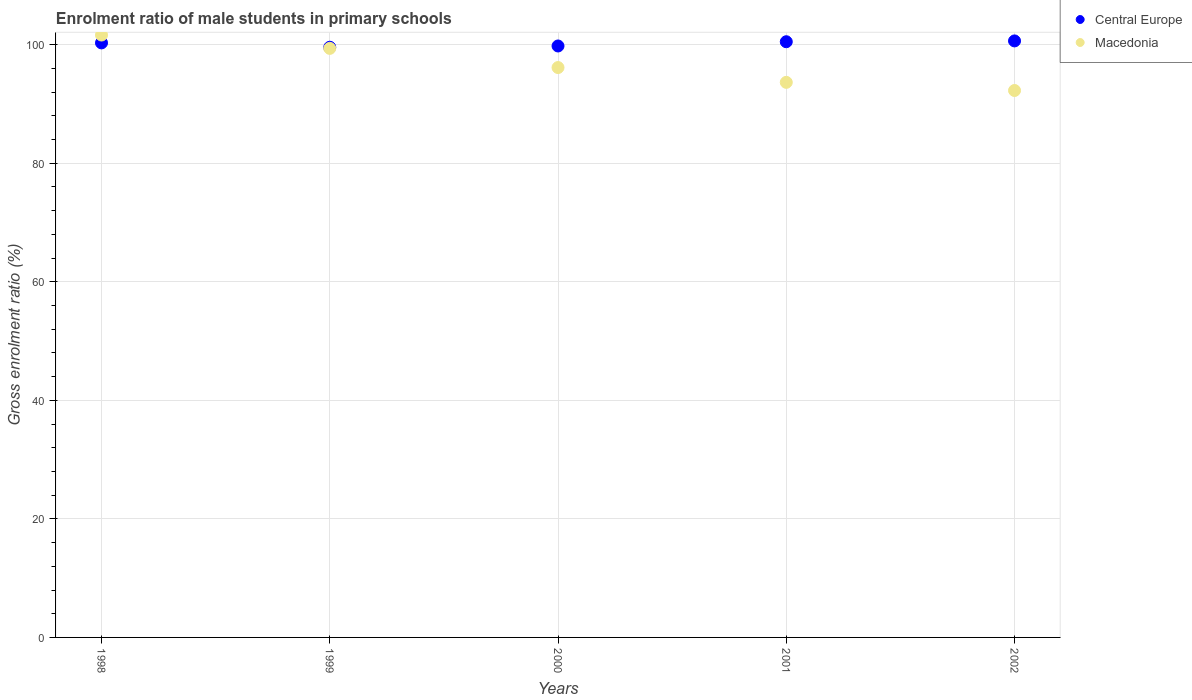Is the number of dotlines equal to the number of legend labels?
Offer a very short reply. Yes. What is the enrolment ratio of male students in primary schools in Macedonia in 2001?
Your answer should be very brief. 93.65. Across all years, what is the maximum enrolment ratio of male students in primary schools in Macedonia?
Keep it short and to the point. 101.64. Across all years, what is the minimum enrolment ratio of male students in primary schools in Central Europe?
Make the answer very short. 99.58. What is the total enrolment ratio of male students in primary schools in Central Europe in the graph?
Ensure brevity in your answer.  500.82. What is the difference between the enrolment ratio of male students in primary schools in Central Europe in 1998 and that in 2000?
Your response must be concise. 0.52. What is the difference between the enrolment ratio of male students in primary schools in Central Europe in 1999 and the enrolment ratio of male students in primary schools in Macedonia in 2000?
Keep it short and to the point. 3.43. What is the average enrolment ratio of male students in primary schools in Macedonia per year?
Your response must be concise. 96.62. In the year 1999, what is the difference between the enrolment ratio of male students in primary schools in Central Europe and enrolment ratio of male students in primary schools in Macedonia?
Give a very brief answer. 0.19. In how many years, is the enrolment ratio of male students in primary schools in Central Europe greater than 88 %?
Provide a succinct answer. 5. What is the ratio of the enrolment ratio of male students in primary schools in Macedonia in 2000 to that in 2002?
Provide a short and direct response. 1.04. Is the enrolment ratio of male students in primary schools in Central Europe in 1998 less than that in 1999?
Your answer should be compact. No. Is the difference between the enrolment ratio of male students in primary schools in Central Europe in 1998 and 2000 greater than the difference between the enrolment ratio of male students in primary schools in Macedonia in 1998 and 2000?
Make the answer very short. No. What is the difference between the highest and the second highest enrolment ratio of male students in primary schools in Central Europe?
Provide a short and direct response. 0.14. What is the difference between the highest and the lowest enrolment ratio of male students in primary schools in Central Europe?
Offer a very short reply. 1.07. In how many years, is the enrolment ratio of male students in primary schools in Central Europe greater than the average enrolment ratio of male students in primary schools in Central Europe taken over all years?
Your response must be concise. 3. Is the sum of the enrolment ratio of male students in primary schools in Central Europe in 1998 and 2001 greater than the maximum enrolment ratio of male students in primary schools in Macedonia across all years?
Offer a terse response. Yes. Is the enrolment ratio of male students in primary schools in Central Europe strictly greater than the enrolment ratio of male students in primary schools in Macedonia over the years?
Offer a very short reply. No. Is the enrolment ratio of male students in primary schools in Central Europe strictly less than the enrolment ratio of male students in primary schools in Macedonia over the years?
Provide a succinct answer. No. What is the difference between two consecutive major ticks on the Y-axis?
Make the answer very short. 20. Are the values on the major ticks of Y-axis written in scientific E-notation?
Offer a very short reply. No. What is the title of the graph?
Your answer should be compact. Enrolment ratio of male students in primary schools. Does "Jamaica" appear as one of the legend labels in the graph?
Give a very brief answer. No. What is the label or title of the X-axis?
Make the answer very short. Years. What is the label or title of the Y-axis?
Give a very brief answer. Gross enrolment ratio (%). What is the Gross enrolment ratio (%) of Central Europe in 1998?
Ensure brevity in your answer.  100.31. What is the Gross enrolment ratio (%) of Macedonia in 1998?
Offer a very short reply. 101.64. What is the Gross enrolment ratio (%) of Central Europe in 1999?
Give a very brief answer. 99.58. What is the Gross enrolment ratio (%) in Macedonia in 1999?
Offer a terse response. 99.38. What is the Gross enrolment ratio (%) in Central Europe in 2000?
Offer a very short reply. 99.79. What is the Gross enrolment ratio (%) in Macedonia in 2000?
Your response must be concise. 96.15. What is the Gross enrolment ratio (%) of Central Europe in 2001?
Make the answer very short. 100.5. What is the Gross enrolment ratio (%) in Macedonia in 2001?
Ensure brevity in your answer.  93.65. What is the Gross enrolment ratio (%) of Central Europe in 2002?
Your answer should be very brief. 100.64. What is the Gross enrolment ratio (%) in Macedonia in 2002?
Ensure brevity in your answer.  92.28. Across all years, what is the maximum Gross enrolment ratio (%) in Central Europe?
Offer a terse response. 100.64. Across all years, what is the maximum Gross enrolment ratio (%) of Macedonia?
Your response must be concise. 101.64. Across all years, what is the minimum Gross enrolment ratio (%) in Central Europe?
Keep it short and to the point. 99.58. Across all years, what is the minimum Gross enrolment ratio (%) in Macedonia?
Keep it short and to the point. 92.28. What is the total Gross enrolment ratio (%) of Central Europe in the graph?
Your response must be concise. 500.82. What is the total Gross enrolment ratio (%) of Macedonia in the graph?
Your answer should be compact. 483.1. What is the difference between the Gross enrolment ratio (%) of Central Europe in 1998 and that in 1999?
Ensure brevity in your answer.  0.73. What is the difference between the Gross enrolment ratio (%) of Macedonia in 1998 and that in 1999?
Ensure brevity in your answer.  2.25. What is the difference between the Gross enrolment ratio (%) in Central Europe in 1998 and that in 2000?
Provide a short and direct response. 0.52. What is the difference between the Gross enrolment ratio (%) in Macedonia in 1998 and that in 2000?
Make the answer very short. 5.49. What is the difference between the Gross enrolment ratio (%) of Central Europe in 1998 and that in 2001?
Ensure brevity in your answer.  -0.2. What is the difference between the Gross enrolment ratio (%) in Macedonia in 1998 and that in 2001?
Your answer should be compact. 7.99. What is the difference between the Gross enrolment ratio (%) of Central Europe in 1998 and that in 2002?
Offer a very short reply. -0.33. What is the difference between the Gross enrolment ratio (%) in Macedonia in 1998 and that in 2002?
Give a very brief answer. 9.36. What is the difference between the Gross enrolment ratio (%) in Central Europe in 1999 and that in 2000?
Keep it short and to the point. -0.21. What is the difference between the Gross enrolment ratio (%) of Macedonia in 1999 and that in 2000?
Provide a short and direct response. 3.23. What is the difference between the Gross enrolment ratio (%) in Central Europe in 1999 and that in 2001?
Provide a succinct answer. -0.93. What is the difference between the Gross enrolment ratio (%) in Macedonia in 1999 and that in 2001?
Your answer should be very brief. 5.73. What is the difference between the Gross enrolment ratio (%) in Central Europe in 1999 and that in 2002?
Offer a terse response. -1.07. What is the difference between the Gross enrolment ratio (%) of Macedonia in 1999 and that in 2002?
Offer a very short reply. 7.11. What is the difference between the Gross enrolment ratio (%) of Central Europe in 2000 and that in 2001?
Give a very brief answer. -0.72. What is the difference between the Gross enrolment ratio (%) of Macedonia in 2000 and that in 2001?
Keep it short and to the point. 2.5. What is the difference between the Gross enrolment ratio (%) in Central Europe in 2000 and that in 2002?
Keep it short and to the point. -0.85. What is the difference between the Gross enrolment ratio (%) in Macedonia in 2000 and that in 2002?
Your answer should be very brief. 3.87. What is the difference between the Gross enrolment ratio (%) of Central Europe in 2001 and that in 2002?
Your answer should be very brief. -0.14. What is the difference between the Gross enrolment ratio (%) of Macedonia in 2001 and that in 2002?
Make the answer very short. 1.37. What is the difference between the Gross enrolment ratio (%) in Central Europe in 1998 and the Gross enrolment ratio (%) in Macedonia in 1999?
Keep it short and to the point. 0.93. What is the difference between the Gross enrolment ratio (%) in Central Europe in 1998 and the Gross enrolment ratio (%) in Macedonia in 2000?
Provide a short and direct response. 4.16. What is the difference between the Gross enrolment ratio (%) in Central Europe in 1998 and the Gross enrolment ratio (%) in Macedonia in 2001?
Offer a very short reply. 6.66. What is the difference between the Gross enrolment ratio (%) of Central Europe in 1998 and the Gross enrolment ratio (%) of Macedonia in 2002?
Give a very brief answer. 8.03. What is the difference between the Gross enrolment ratio (%) of Central Europe in 1999 and the Gross enrolment ratio (%) of Macedonia in 2000?
Give a very brief answer. 3.43. What is the difference between the Gross enrolment ratio (%) in Central Europe in 1999 and the Gross enrolment ratio (%) in Macedonia in 2001?
Your answer should be compact. 5.92. What is the difference between the Gross enrolment ratio (%) in Central Europe in 1999 and the Gross enrolment ratio (%) in Macedonia in 2002?
Keep it short and to the point. 7.3. What is the difference between the Gross enrolment ratio (%) in Central Europe in 2000 and the Gross enrolment ratio (%) in Macedonia in 2001?
Offer a terse response. 6.14. What is the difference between the Gross enrolment ratio (%) of Central Europe in 2000 and the Gross enrolment ratio (%) of Macedonia in 2002?
Keep it short and to the point. 7.51. What is the difference between the Gross enrolment ratio (%) in Central Europe in 2001 and the Gross enrolment ratio (%) in Macedonia in 2002?
Keep it short and to the point. 8.23. What is the average Gross enrolment ratio (%) of Central Europe per year?
Provide a short and direct response. 100.16. What is the average Gross enrolment ratio (%) of Macedonia per year?
Provide a succinct answer. 96.62. In the year 1998, what is the difference between the Gross enrolment ratio (%) of Central Europe and Gross enrolment ratio (%) of Macedonia?
Provide a short and direct response. -1.33. In the year 1999, what is the difference between the Gross enrolment ratio (%) in Central Europe and Gross enrolment ratio (%) in Macedonia?
Provide a short and direct response. 0.19. In the year 2000, what is the difference between the Gross enrolment ratio (%) of Central Europe and Gross enrolment ratio (%) of Macedonia?
Your answer should be compact. 3.64. In the year 2001, what is the difference between the Gross enrolment ratio (%) of Central Europe and Gross enrolment ratio (%) of Macedonia?
Ensure brevity in your answer.  6.85. In the year 2002, what is the difference between the Gross enrolment ratio (%) of Central Europe and Gross enrolment ratio (%) of Macedonia?
Keep it short and to the point. 8.37. What is the ratio of the Gross enrolment ratio (%) in Central Europe in 1998 to that in 1999?
Provide a succinct answer. 1.01. What is the ratio of the Gross enrolment ratio (%) of Macedonia in 1998 to that in 1999?
Offer a terse response. 1.02. What is the ratio of the Gross enrolment ratio (%) of Macedonia in 1998 to that in 2000?
Provide a succinct answer. 1.06. What is the ratio of the Gross enrolment ratio (%) of Central Europe in 1998 to that in 2001?
Give a very brief answer. 1. What is the ratio of the Gross enrolment ratio (%) of Macedonia in 1998 to that in 2001?
Your answer should be very brief. 1.09. What is the ratio of the Gross enrolment ratio (%) of Macedonia in 1998 to that in 2002?
Provide a succinct answer. 1.1. What is the ratio of the Gross enrolment ratio (%) of Macedonia in 1999 to that in 2000?
Ensure brevity in your answer.  1.03. What is the ratio of the Gross enrolment ratio (%) of Macedonia in 1999 to that in 2001?
Provide a succinct answer. 1.06. What is the ratio of the Gross enrolment ratio (%) of Macedonia in 1999 to that in 2002?
Offer a terse response. 1.08. What is the ratio of the Gross enrolment ratio (%) of Central Europe in 2000 to that in 2001?
Make the answer very short. 0.99. What is the ratio of the Gross enrolment ratio (%) in Macedonia in 2000 to that in 2001?
Keep it short and to the point. 1.03. What is the ratio of the Gross enrolment ratio (%) in Macedonia in 2000 to that in 2002?
Offer a terse response. 1.04. What is the ratio of the Gross enrolment ratio (%) in Central Europe in 2001 to that in 2002?
Ensure brevity in your answer.  1. What is the ratio of the Gross enrolment ratio (%) of Macedonia in 2001 to that in 2002?
Keep it short and to the point. 1.01. What is the difference between the highest and the second highest Gross enrolment ratio (%) in Central Europe?
Make the answer very short. 0.14. What is the difference between the highest and the second highest Gross enrolment ratio (%) in Macedonia?
Your answer should be compact. 2.25. What is the difference between the highest and the lowest Gross enrolment ratio (%) of Central Europe?
Offer a very short reply. 1.07. What is the difference between the highest and the lowest Gross enrolment ratio (%) of Macedonia?
Give a very brief answer. 9.36. 